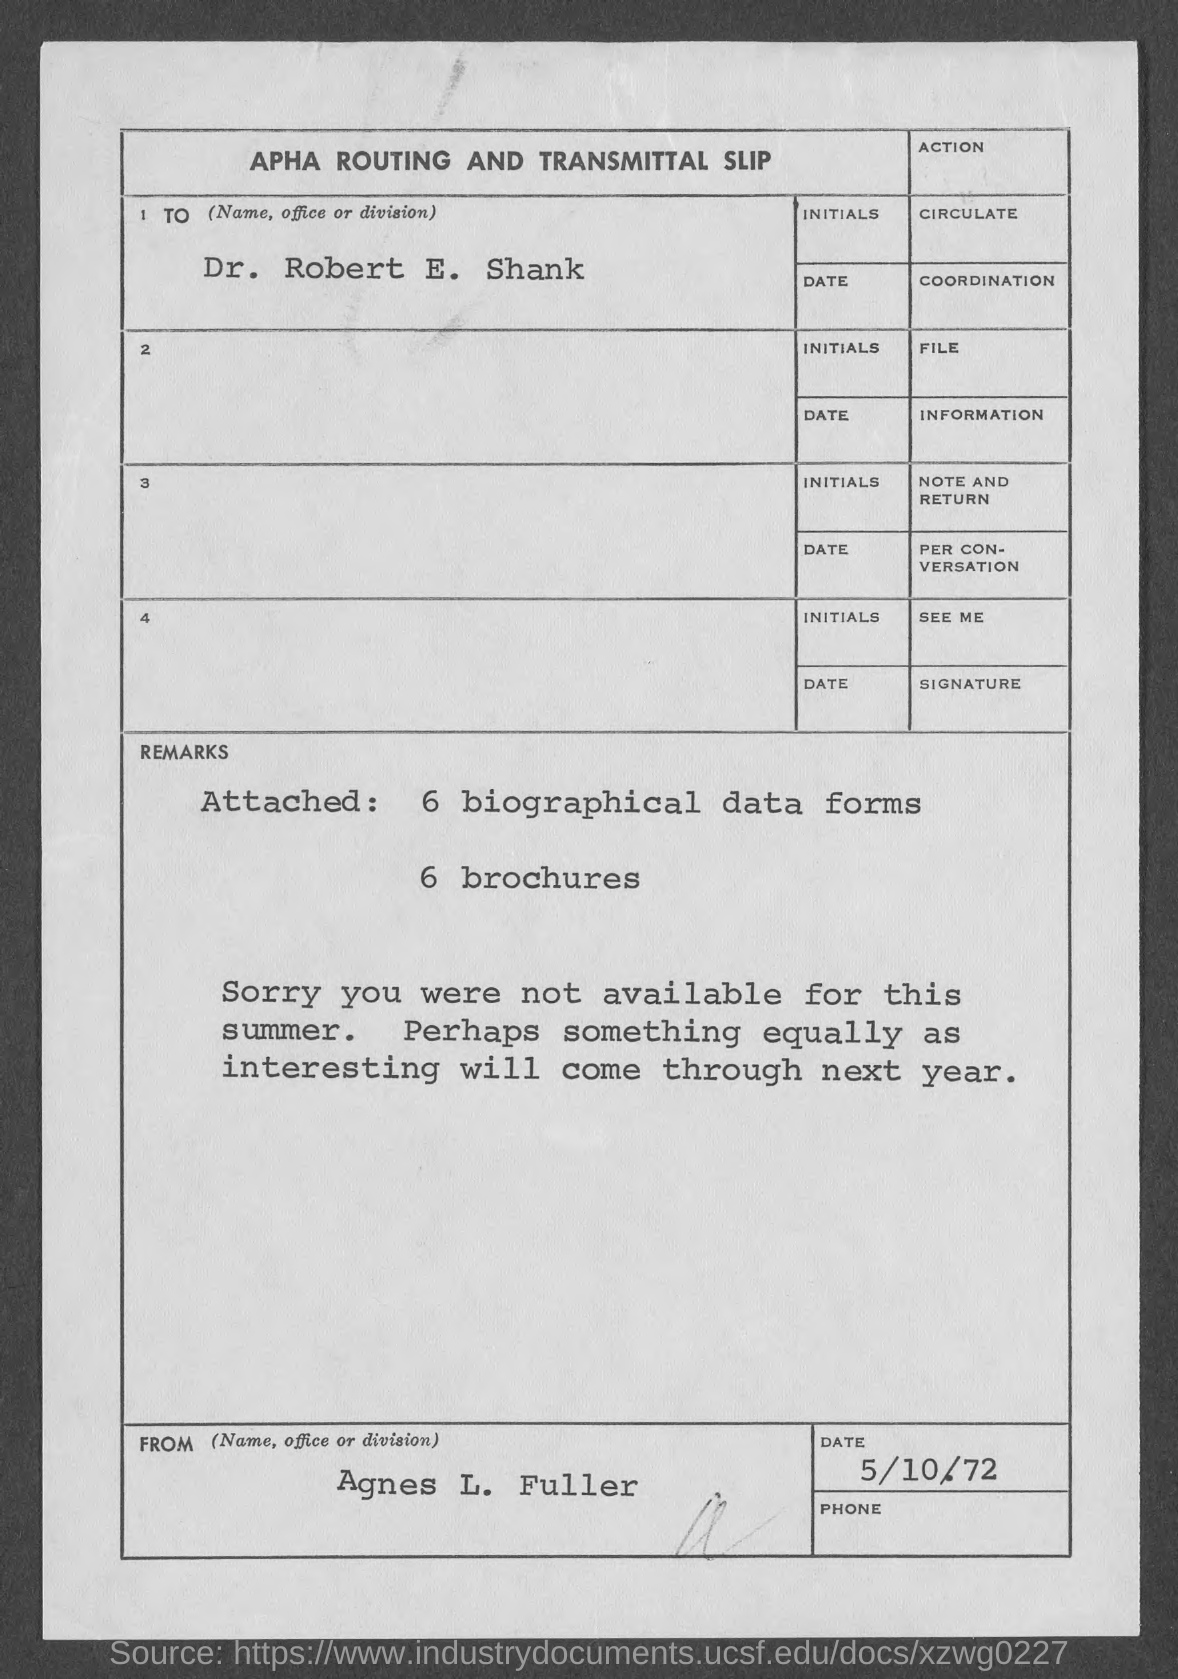Give some essential details in this illustration. Six brochures are attached. It can be inferred that the individual was not available during the summer season. The date on the document is May 10th, 1972. The name is Dr. Robert E. Shank. Six biographical data forms are attached. 